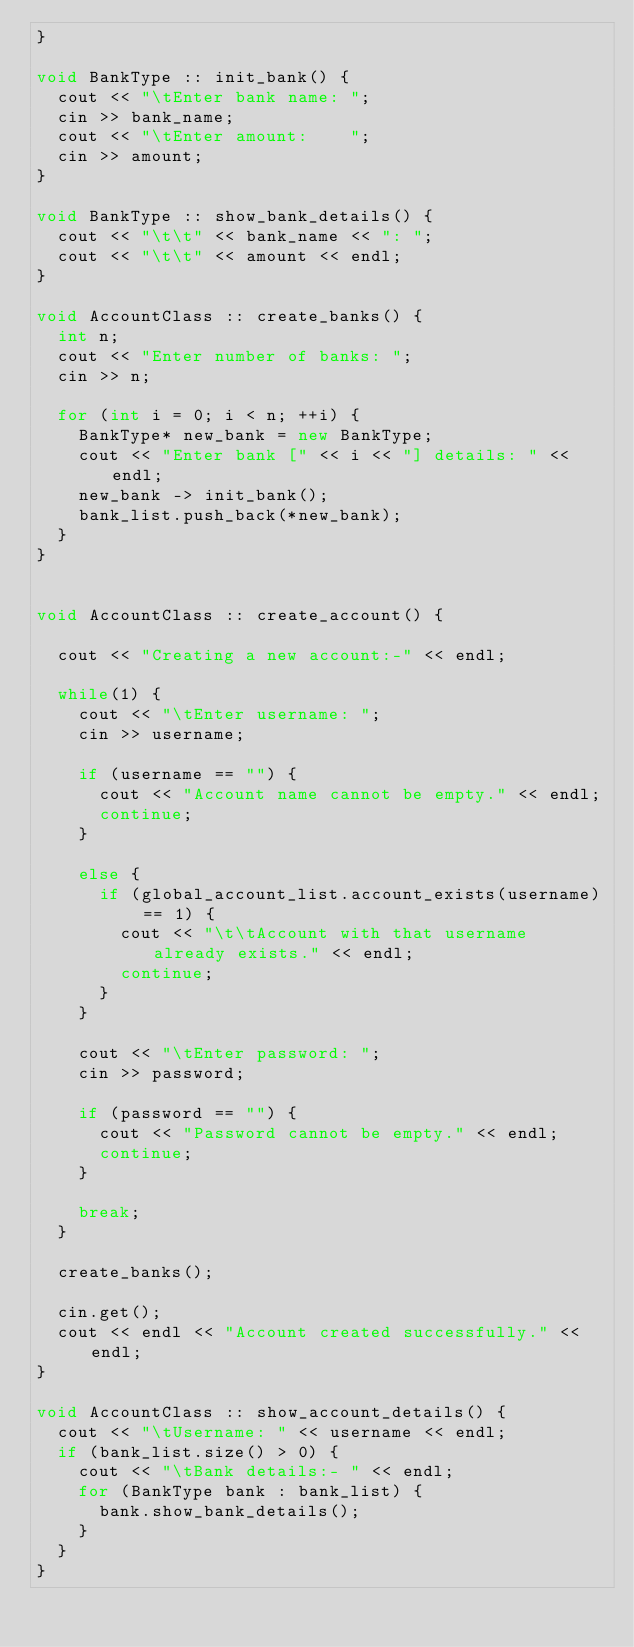Convert code to text. <code><loc_0><loc_0><loc_500><loc_500><_C++_>}

void BankType :: init_bank() {
	cout << "\tEnter bank name: ";
	cin >> bank_name;
	cout << "\tEnter amount:    ";
	cin >> amount;
}

void BankType :: show_bank_details() {
	cout << "\t\t" << bank_name << ": ";
	cout << "\t\t" << amount << endl;
}

void AccountClass :: create_banks() {
	int n;
	cout << "Enter number of banks: ";
	cin >> n;
	
	for (int i = 0; i < n; ++i) {
		BankType* new_bank = new BankType;
		cout << "Enter bank [" << i << "] details: " << endl;
		new_bank -> init_bank();
		bank_list.push_back(*new_bank);
	}
}


void AccountClass :: create_account() {
	
	cout << "Creating a new account:-" << endl;
	
	while(1) {
		cout << "\tEnter username: ";
		cin >> username;
		
		if (username == "") {
			cout << "Account name cannot be empty." << endl;
			continue;
		}
		
		else {
			if (global_account_list.account_exists(username) == 1) {
				cout << "\t\tAccount with that username already exists." << endl;
				continue;
			}
		}
		
		cout << "\tEnter password: ";
		cin >> password;
		
		if (password == "") {
			cout << "Password cannot be empty." << endl;
			continue;
		}
		
		break;
	}
	
	create_banks();
	
	cin.get();
	cout << endl << "Account created successfully." << endl;
}

void AccountClass :: show_account_details() {
	cout << "\tUsername: " << username << endl;
	if (bank_list.size() > 0) {
		cout << "\tBank details:- " << endl;
		for (BankType bank : bank_list) {
			bank.show_bank_details();
		}
	}
}
</code> 